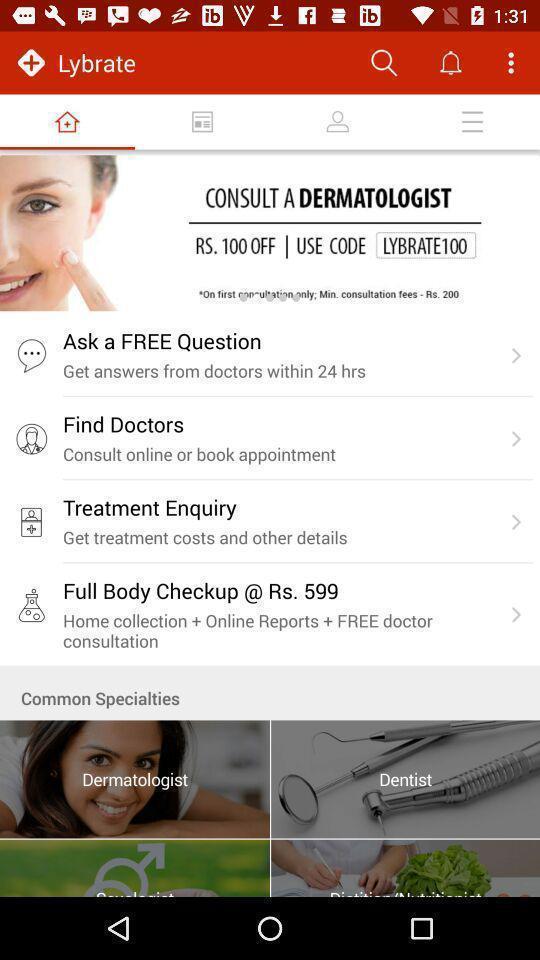Provide a textual representation of this image. Welcome page. 